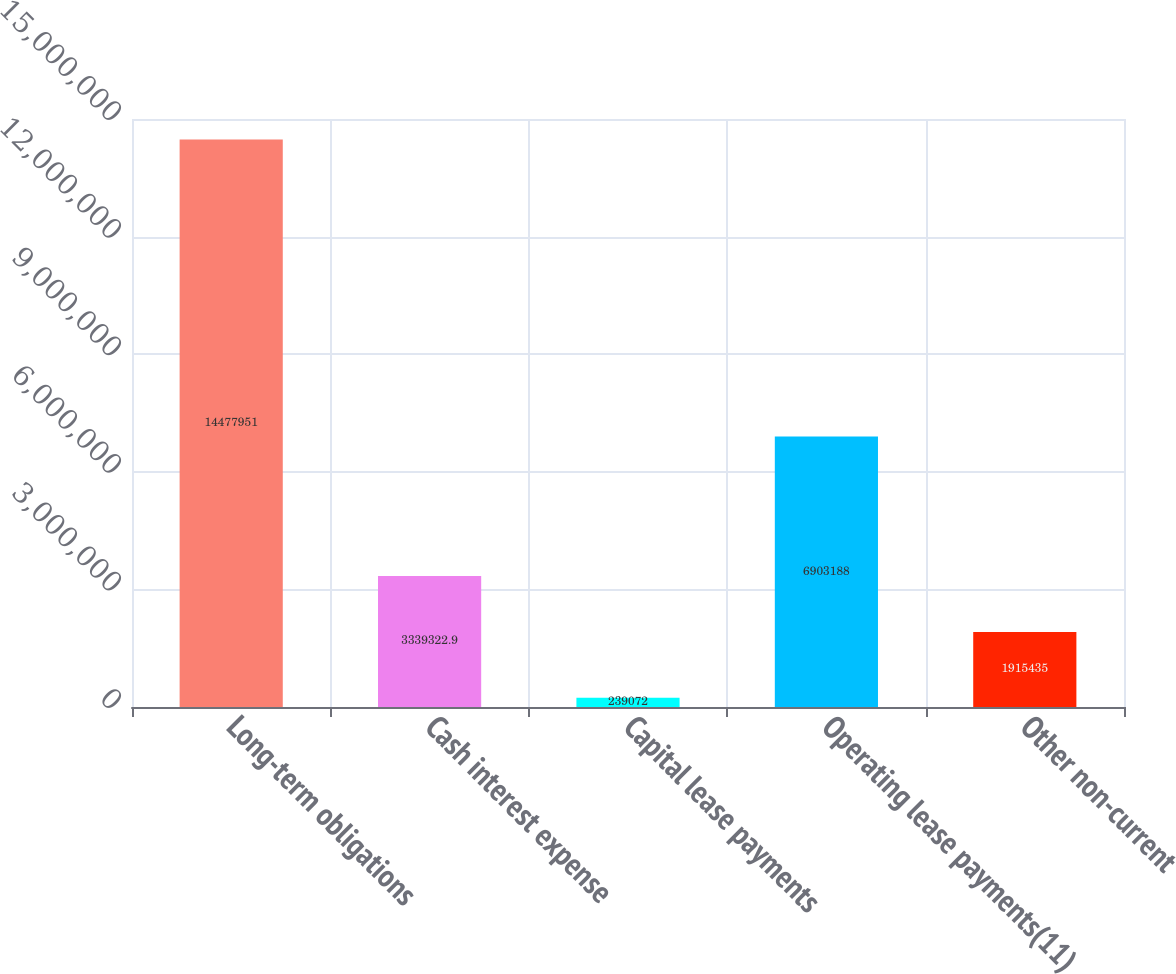<chart> <loc_0><loc_0><loc_500><loc_500><bar_chart><fcel>Long-term obligations<fcel>Cash interest expense<fcel>Capital lease payments<fcel>Operating lease payments(11)<fcel>Other non-current<nl><fcel>1.4478e+07<fcel>3.33932e+06<fcel>239072<fcel>6.90319e+06<fcel>1.91544e+06<nl></chart> 